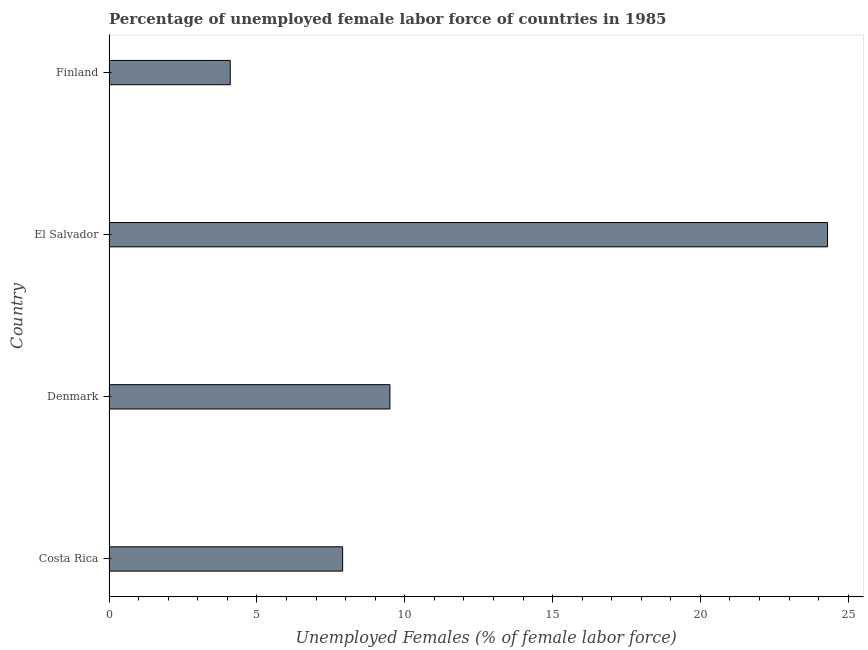Does the graph contain any zero values?
Provide a short and direct response. No. What is the title of the graph?
Your answer should be very brief. Percentage of unemployed female labor force of countries in 1985. What is the label or title of the X-axis?
Provide a short and direct response. Unemployed Females (% of female labor force). What is the label or title of the Y-axis?
Make the answer very short. Country. What is the total unemployed female labour force in Finland?
Make the answer very short. 4.1. Across all countries, what is the maximum total unemployed female labour force?
Your response must be concise. 24.3. Across all countries, what is the minimum total unemployed female labour force?
Ensure brevity in your answer.  4.1. In which country was the total unemployed female labour force maximum?
Your answer should be compact. El Salvador. What is the sum of the total unemployed female labour force?
Provide a succinct answer. 45.8. What is the difference between the total unemployed female labour force in Denmark and El Salvador?
Your answer should be compact. -14.8. What is the average total unemployed female labour force per country?
Offer a very short reply. 11.45. What is the median total unemployed female labour force?
Provide a short and direct response. 8.7. What is the ratio of the total unemployed female labour force in Denmark to that in El Salvador?
Make the answer very short. 0.39. Is the total unemployed female labour force in Denmark less than that in El Salvador?
Make the answer very short. Yes. Is the difference between the total unemployed female labour force in Denmark and El Salvador greater than the difference between any two countries?
Offer a very short reply. No. What is the difference between the highest and the second highest total unemployed female labour force?
Make the answer very short. 14.8. Is the sum of the total unemployed female labour force in Denmark and El Salvador greater than the maximum total unemployed female labour force across all countries?
Your answer should be compact. Yes. What is the difference between the highest and the lowest total unemployed female labour force?
Provide a succinct answer. 20.2. Are all the bars in the graph horizontal?
Offer a terse response. Yes. What is the difference between two consecutive major ticks on the X-axis?
Ensure brevity in your answer.  5. Are the values on the major ticks of X-axis written in scientific E-notation?
Provide a short and direct response. No. What is the Unemployed Females (% of female labor force) in Costa Rica?
Your response must be concise. 7.9. What is the Unemployed Females (% of female labor force) in El Salvador?
Offer a terse response. 24.3. What is the Unemployed Females (% of female labor force) in Finland?
Provide a succinct answer. 4.1. What is the difference between the Unemployed Females (% of female labor force) in Costa Rica and Denmark?
Offer a terse response. -1.6. What is the difference between the Unemployed Females (% of female labor force) in Costa Rica and El Salvador?
Offer a very short reply. -16.4. What is the difference between the Unemployed Females (% of female labor force) in Costa Rica and Finland?
Give a very brief answer. 3.8. What is the difference between the Unemployed Females (% of female labor force) in Denmark and El Salvador?
Ensure brevity in your answer.  -14.8. What is the difference between the Unemployed Females (% of female labor force) in El Salvador and Finland?
Give a very brief answer. 20.2. What is the ratio of the Unemployed Females (% of female labor force) in Costa Rica to that in Denmark?
Your answer should be compact. 0.83. What is the ratio of the Unemployed Females (% of female labor force) in Costa Rica to that in El Salvador?
Provide a succinct answer. 0.33. What is the ratio of the Unemployed Females (% of female labor force) in Costa Rica to that in Finland?
Provide a short and direct response. 1.93. What is the ratio of the Unemployed Females (% of female labor force) in Denmark to that in El Salvador?
Ensure brevity in your answer.  0.39. What is the ratio of the Unemployed Females (% of female labor force) in Denmark to that in Finland?
Provide a succinct answer. 2.32. What is the ratio of the Unemployed Females (% of female labor force) in El Salvador to that in Finland?
Offer a very short reply. 5.93. 